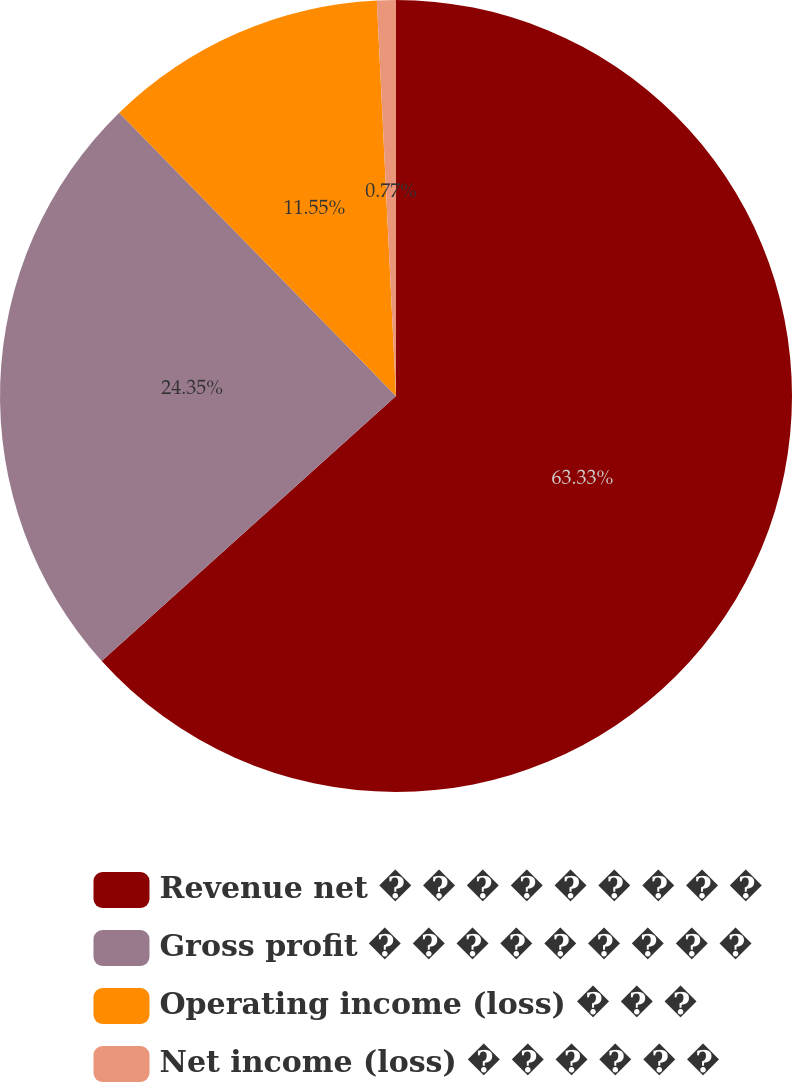Convert chart. <chart><loc_0><loc_0><loc_500><loc_500><pie_chart><fcel>Revenue net � � � � � � � � �<fcel>Gross profit � � � � � � � � �<fcel>Operating income (loss) � � �<fcel>Net income (loss) � � � � � �<nl><fcel>63.34%<fcel>24.35%<fcel>11.55%<fcel>0.77%<nl></chart> 